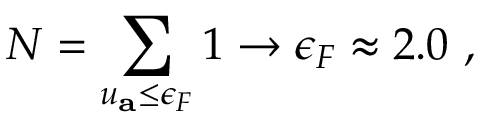<formula> <loc_0><loc_0><loc_500><loc_500>N = \sum _ { u _ { a } \leq \epsilon _ { F } } 1 \rightarrow \epsilon _ { F } \approx 2 . 0 ,</formula> 